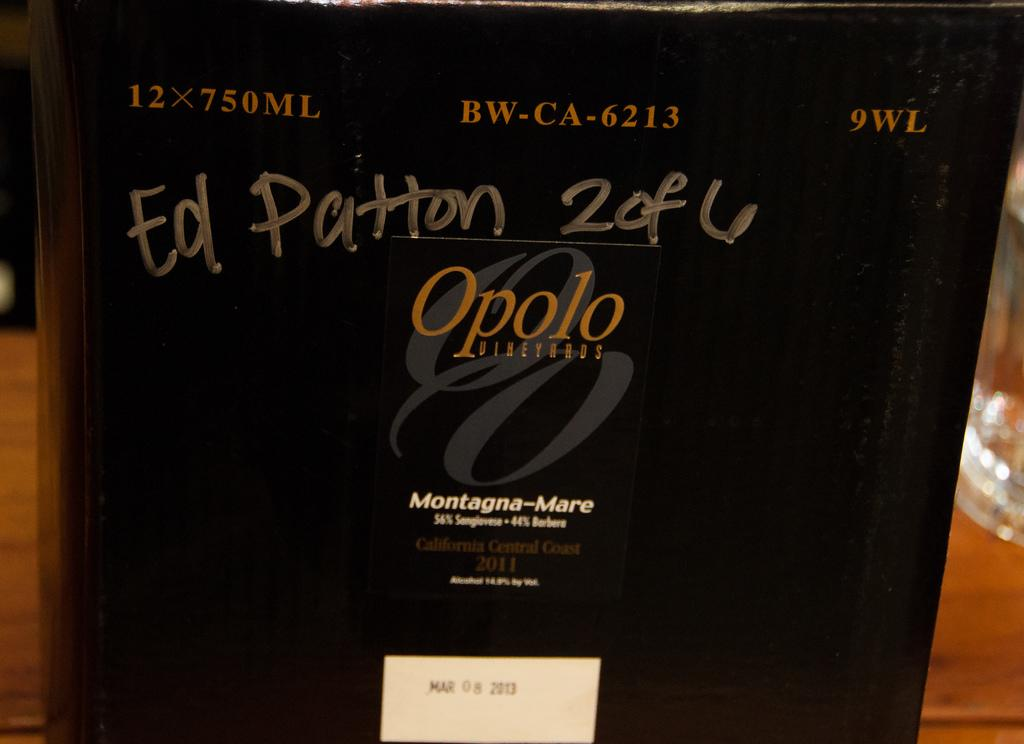<image>
Relay a brief, clear account of the picture shown. Ed Patton is hand written above the logo for Opolo Vineyards. 